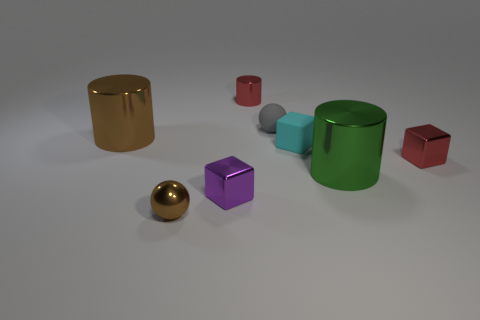Subtract all tiny red metal blocks. How many blocks are left? 2 Add 1 cyan matte objects. How many objects exist? 9 Subtract all balls. How many objects are left? 6 Subtract 0 purple cylinders. How many objects are left? 8 Subtract all tiny gray objects. Subtract all tiny purple things. How many objects are left? 6 Add 6 red metal blocks. How many red metal blocks are left? 7 Add 6 big yellow shiny blocks. How many big yellow shiny blocks exist? 6 